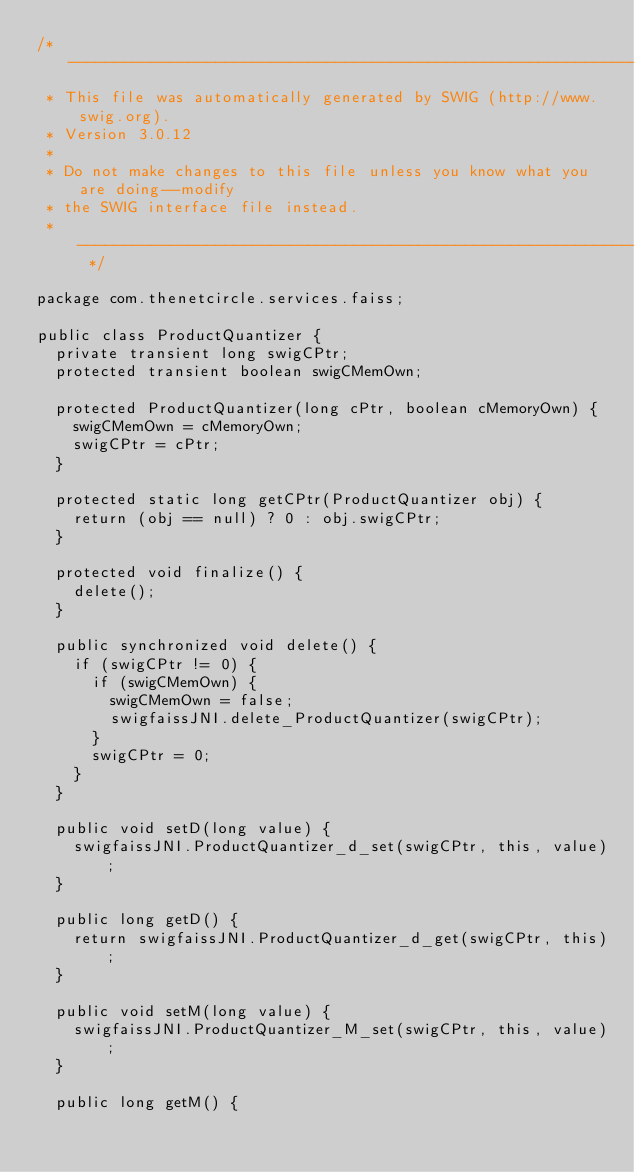Convert code to text. <code><loc_0><loc_0><loc_500><loc_500><_Java_>/* ----------------------------------------------------------------------------
 * This file was automatically generated by SWIG (http://www.swig.org).
 * Version 3.0.12
 *
 * Do not make changes to this file unless you know what you are doing--modify
 * the SWIG interface file instead.
 * ----------------------------------------------------------------------------- */

package com.thenetcircle.services.faiss;

public class ProductQuantizer {
  private transient long swigCPtr;
  protected transient boolean swigCMemOwn;

  protected ProductQuantizer(long cPtr, boolean cMemoryOwn) {
    swigCMemOwn = cMemoryOwn;
    swigCPtr = cPtr;
  }

  protected static long getCPtr(ProductQuantizer obj) {
    return (obj == null) ? 0 : obj.swigCPtr;
  }

  protected void finalize() {
    delete();
  }

  public synchronized void delete() {
    if (swigCPtr != 0) {
      if (swigCMemOwn) {
        swigCMemOwn = false;
        swigfaissJNI.delete_ProductQuantizer(swigCPtr);
      }
      swigCPtr = 0;
    }
  }

  public void setD(long value) {
    swigfaissJNI.ProductQuantizer_d_set(swigCPtr, this, value);
  }

  public long getD() {
    return swigfaissJNI.ProductQuantizer_d_get(swigCPtr, this);
  }

  public void setM(long value) {
    swigfaissJNI.ProductQuantizer_M_set(swigCPtr, this, value);
  }

  public long getM() {</code> 